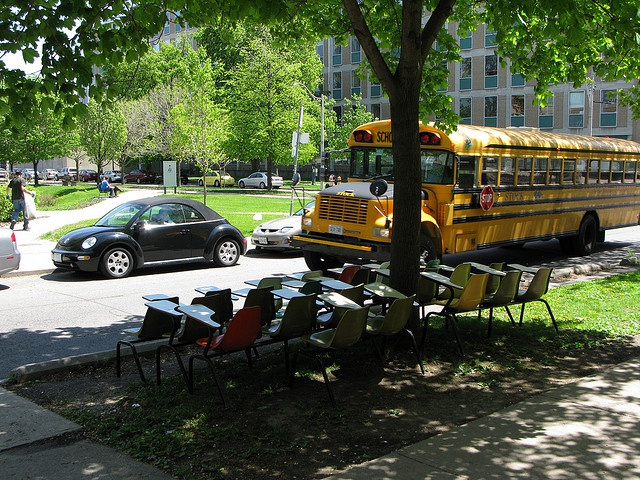Describe the objects in this image and their specific colors. I can see bus in darkgreen, black, olive, and gray tones, car in darkgreen, black, gray, white, and darkgray tones, chair in darkgreen, black, white, gray, and lightblue tones, chair in darkgreen, black, lightblue, maroon, and darkgray tones, and chair in darkgreen, black, white, gray, and darkgray tones in this image. 